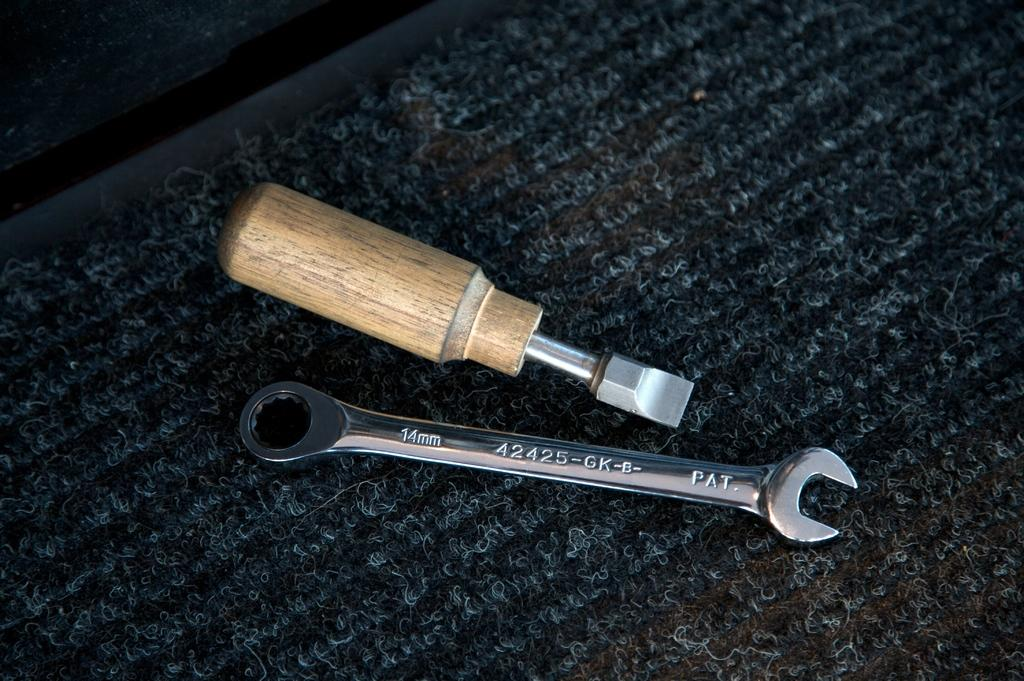What is located in the center of the image? There are objects on a mat in the center of the image. How many snails can be seen crawling on the objects in the image? There are no snails present in the image. What is the distance between the objects on the mat in the image? The distance between the objects on the mat cannot be determined from the image alone, as there is no reference point for measurement. 